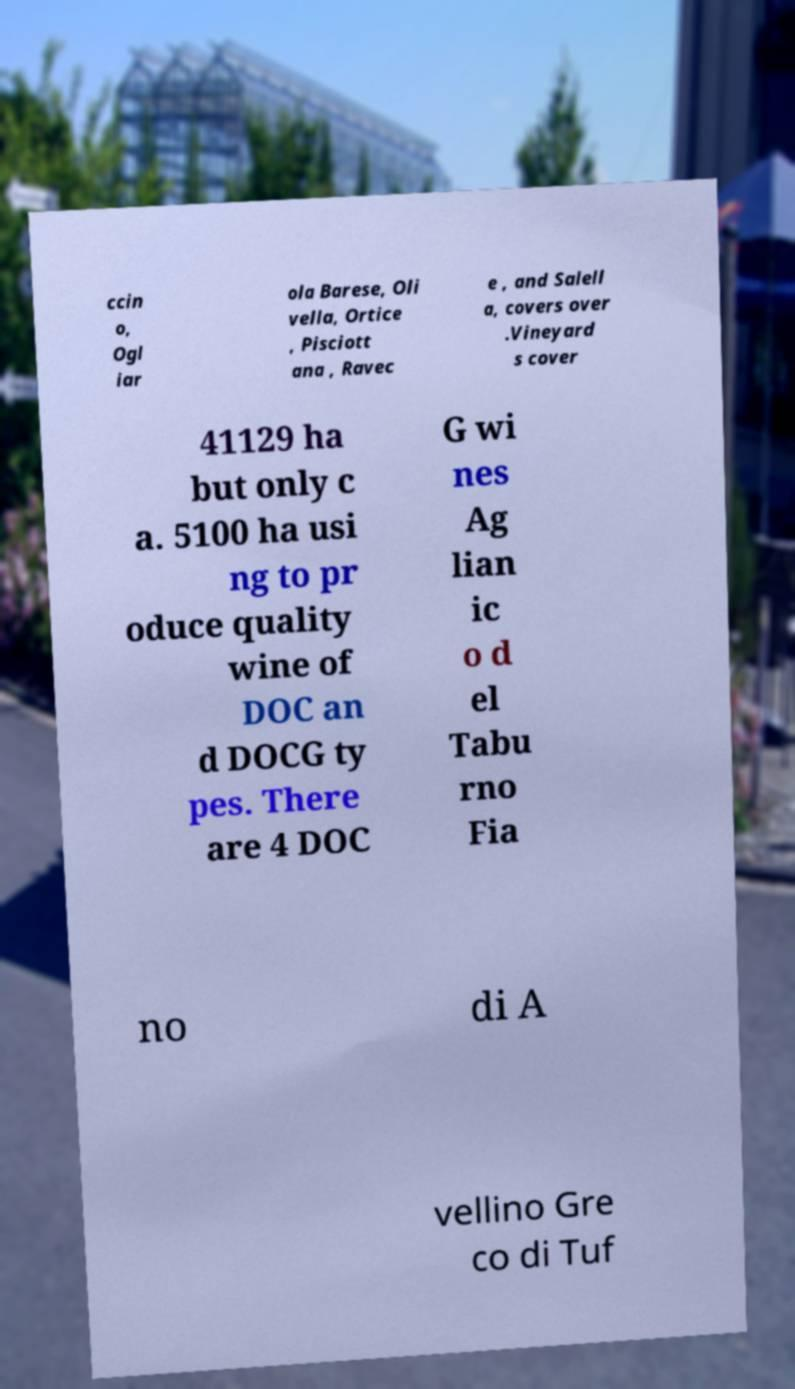Can you accurately transcribe the text from the provided image for me? ccin o, Ogl iar ola Barese, Oli vella, Ortice , Pisciott ana , Ravec e , and Salell a, covers over .Vineyard s cover 41129 ha but only c a. 5100 ha usi ng to pr oduce quality wine of DOC an d DOCG ty pes. There are 4 DOC G wi nes Ag lian ic o d el Tabu rno Fia no di A vellino Gre co di Tuf 